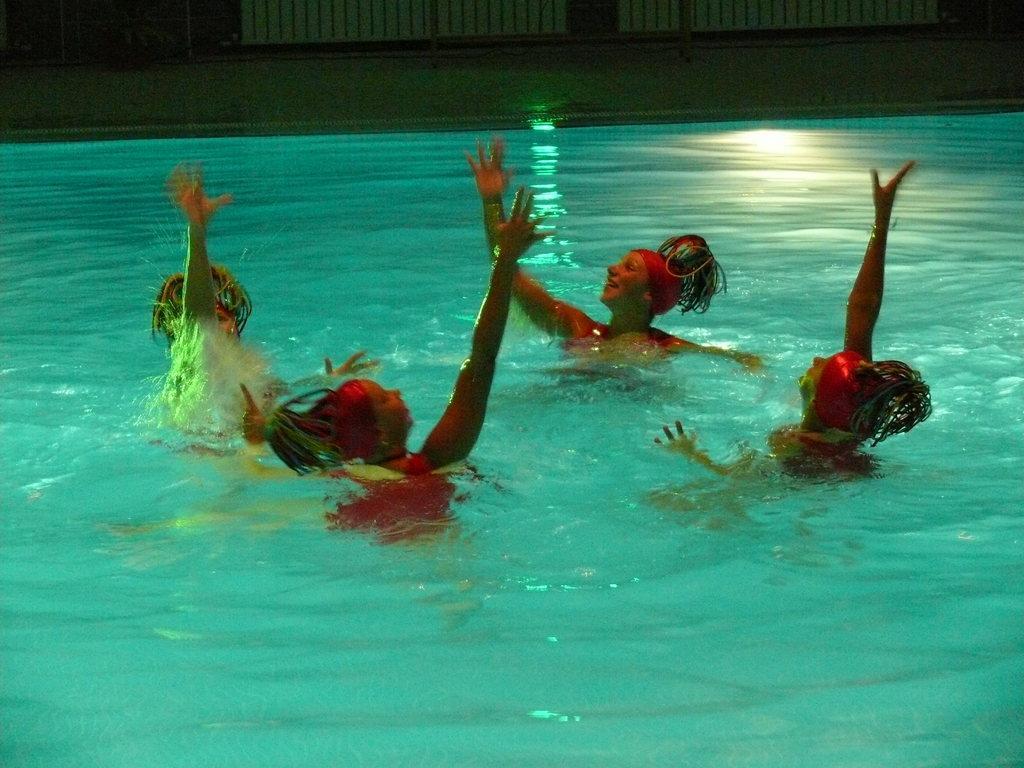Can you describe this image briefly? In this picture we can see people and in the background we can see water and some objects. 